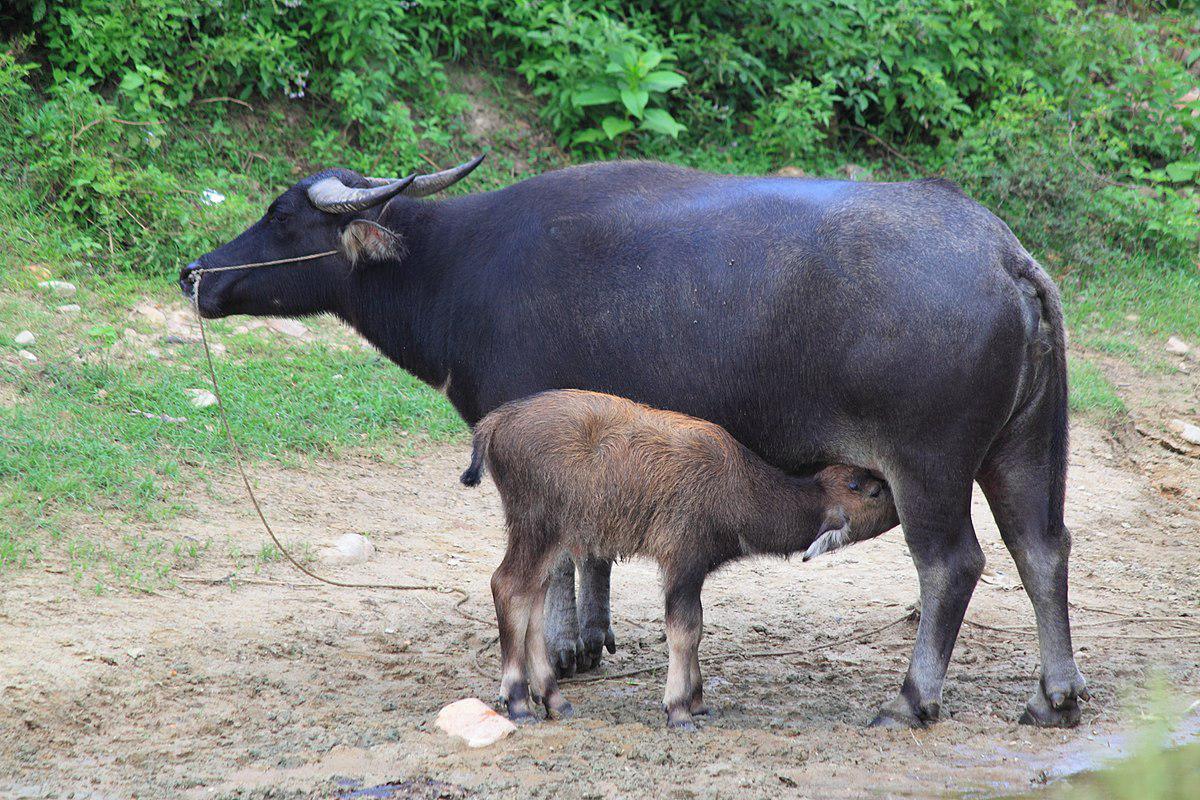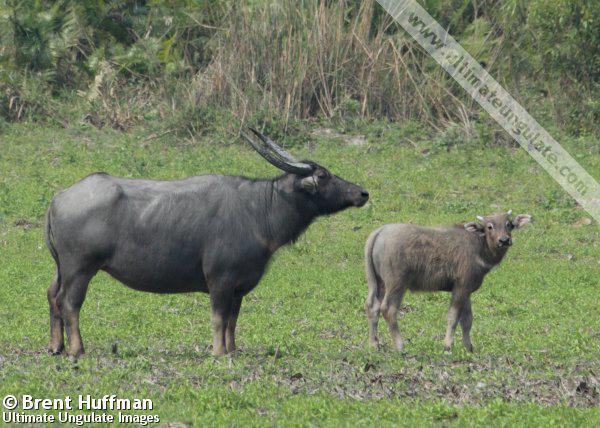The first image is the image on the left, the second image is the image on the right. For the images displayed, is the sentence "A calf is being fed by it's mother" factually correct? Answer yes or no. Yes. 